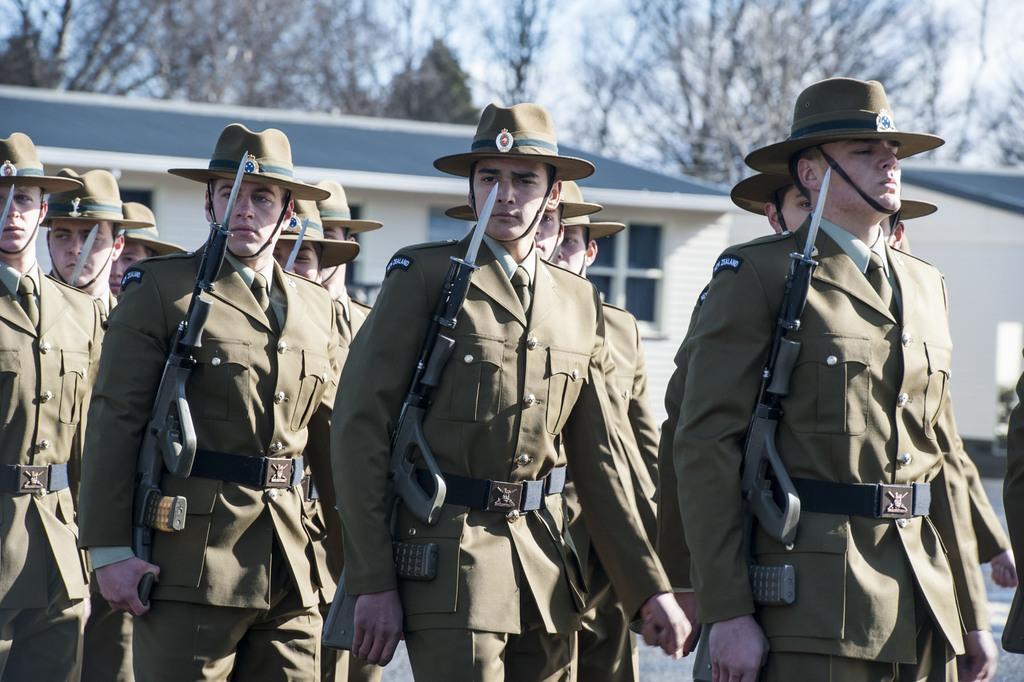In one or two sentences, can you explain what this image depicts? In this image we can see people. They are wearing hats. Some are holding guns. In the background there are buildings with windows. Also there are trees and sky. 